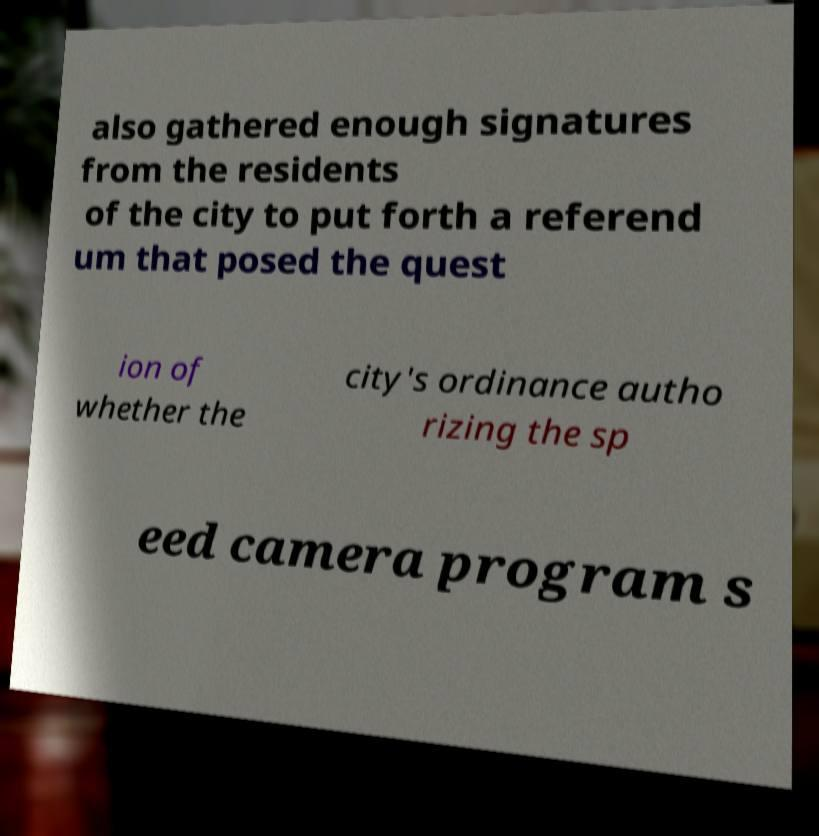Please identify and transcribe the text found in this image. also gathered enough signatures from the residents of the city to put forth a referend um that posed the quest ion of whether the city's ordinance autho rizing the sp eed camera program s 